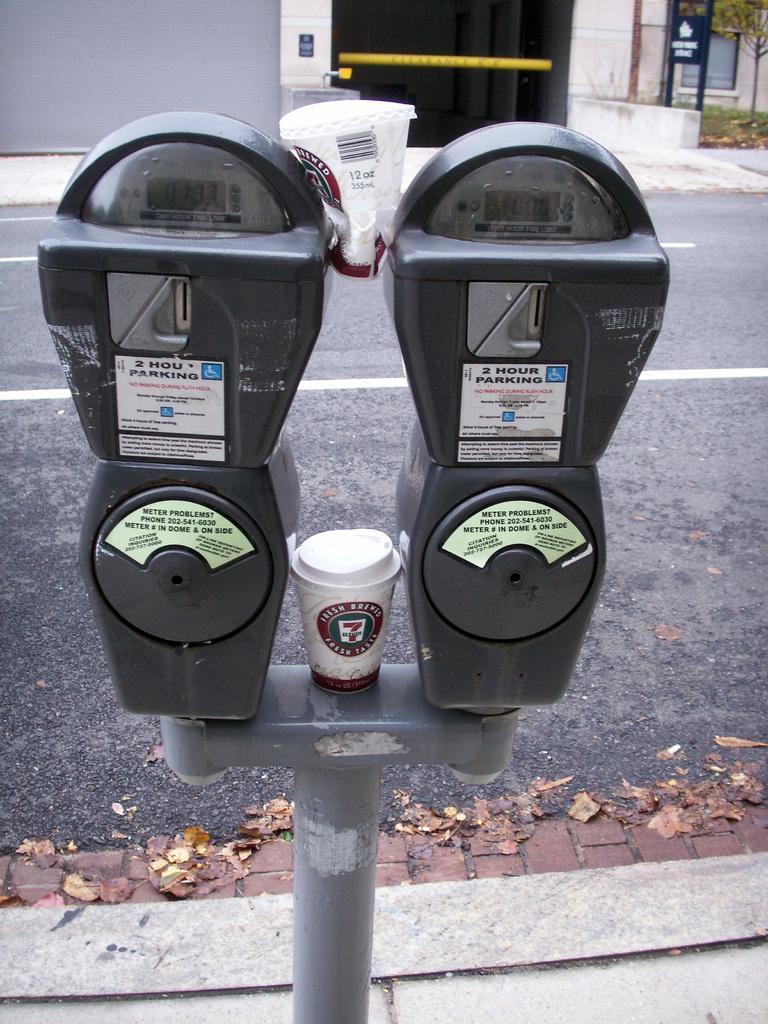Describe this image in one or two sentences. In the center of the image there are parking meters. In the background there is a road and we can see buildings. On the right there is a tree. 